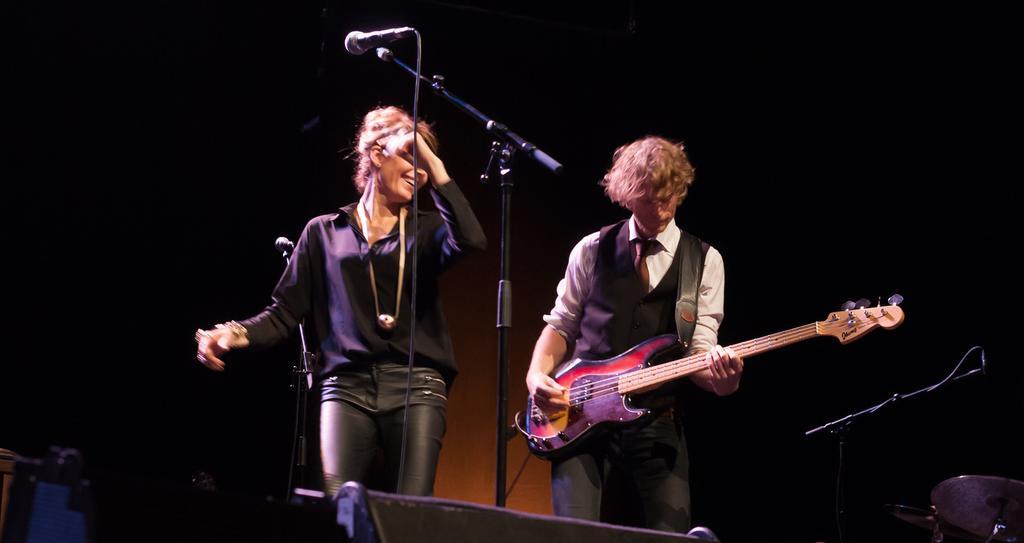How would you summarize this image in a sentence or two? In the middle of the image we can see a microphone. Behind the microphone two persons are standing and he is holding a guitar. In the bottom right corner of the image we can some drums 